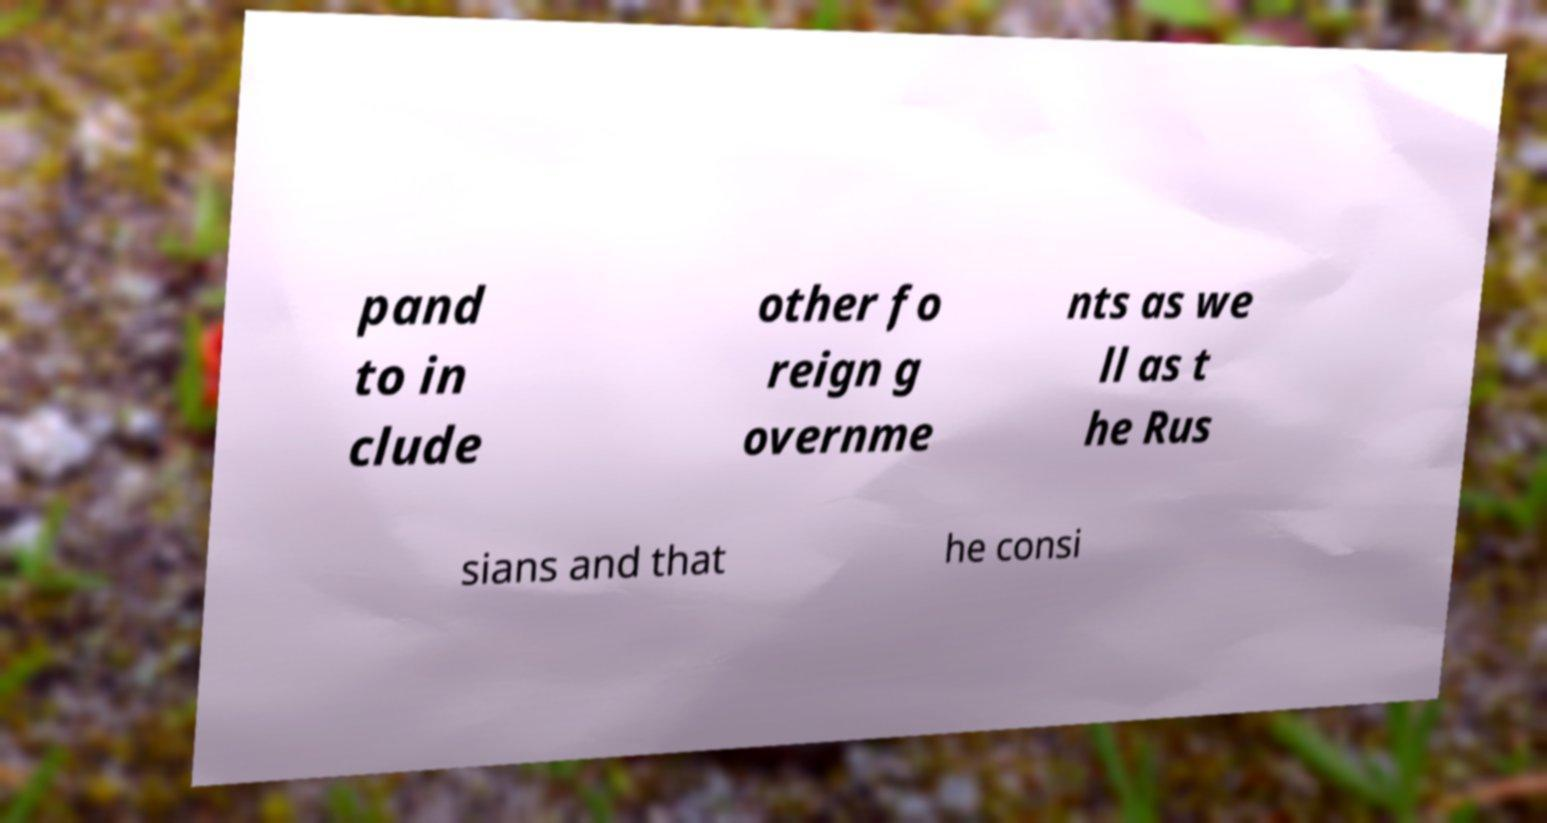Can you accurately transcribe the text from the provided image for me? pand to in clude other fo reign g overnme nts as we ll as t he Rus sians and that he consi 